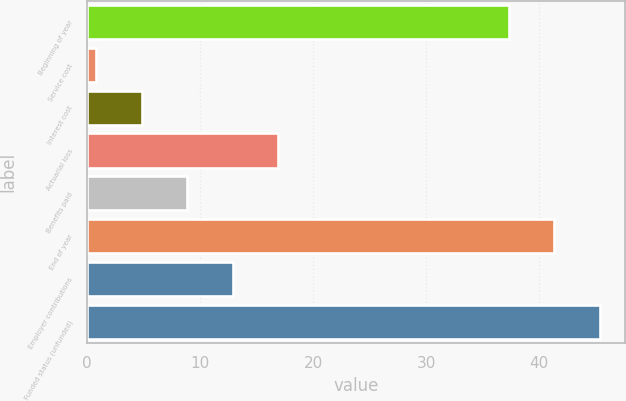Convert chart. <chart><loc_0><loc_0><loc_500><loc_500><bar_chart><fcel>Beginning of year<fcel>Service cost<fcel>Interest cost<fcel>Actuarial loss<fcel>Benefits paid<fcel>End of year<fcel>Employer contributions<fcel>Funded status (unfunded)<nl><fcel>37.3<fcel>0.8<fcel>4.83<fcel>16.92<fcel>8.86<fcel>41.33<fcel>12.89<fcel>45.36<nl></chart> 